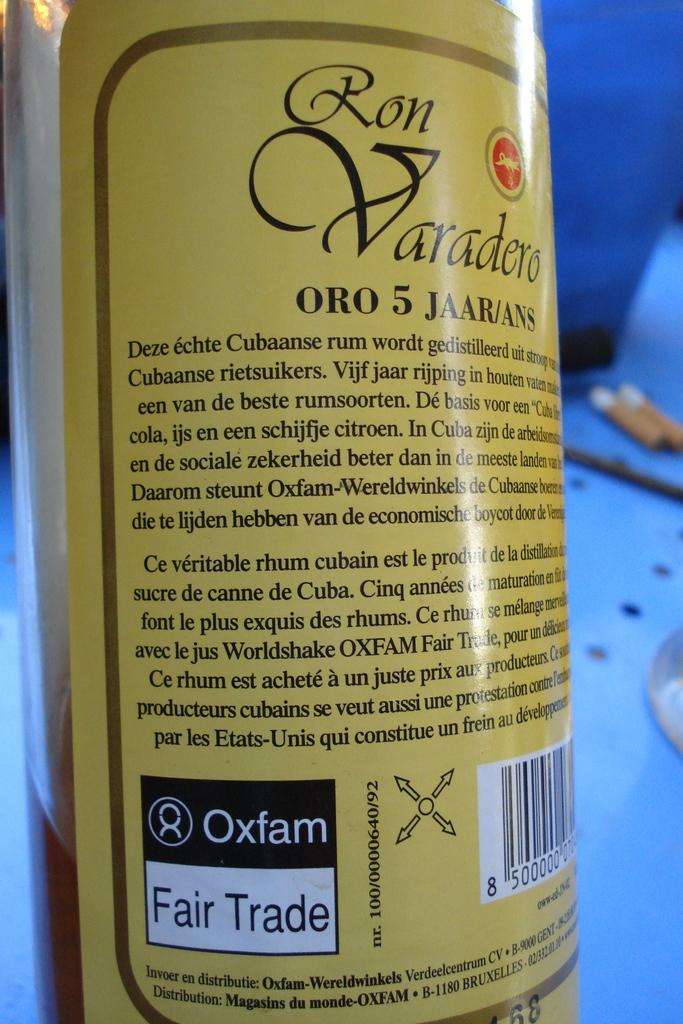Provide a one-sentence caption for the provided image. A bottle of rum labeled Ron Varadero Oro 5 Jaar/Ans. 